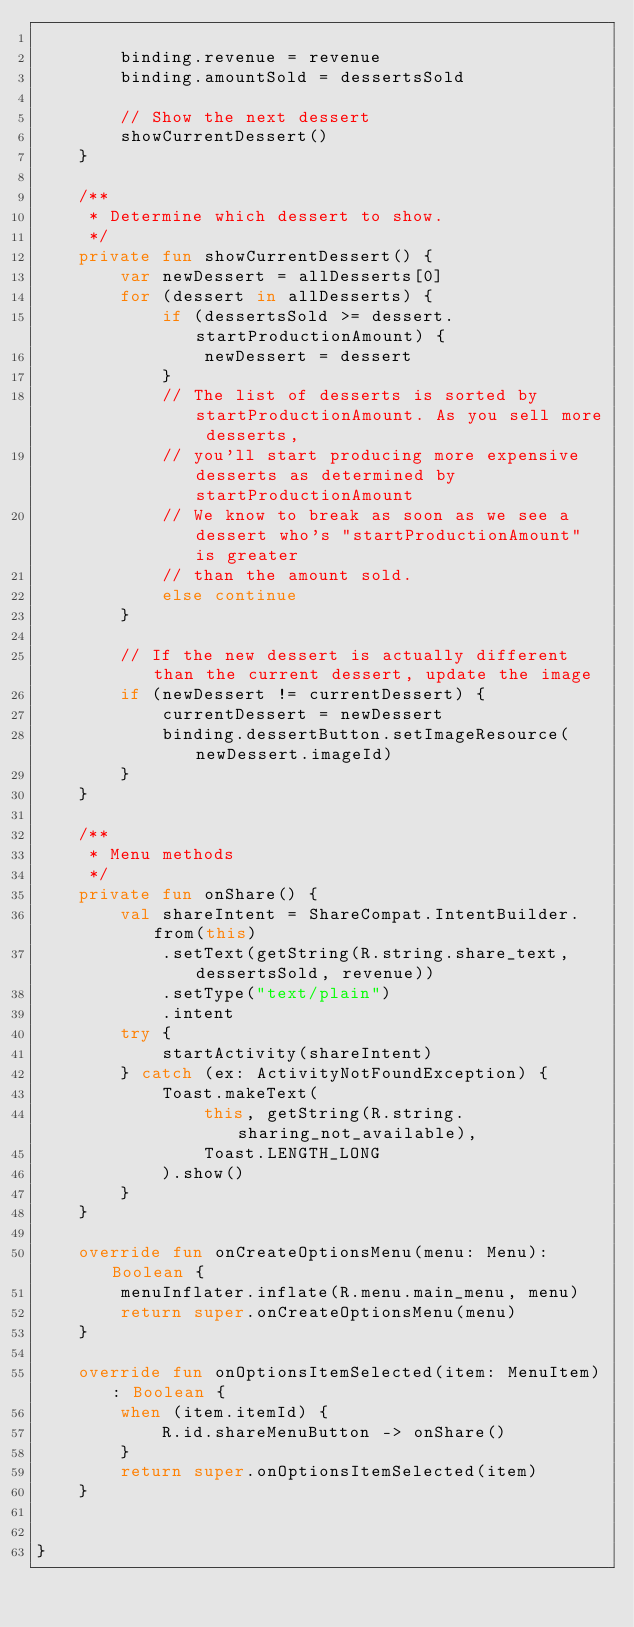Convert code to text. <code><loc_0><loc_0><loc_500><loc_500><_Kotlin_>
        binding.revenue = revenue
        binding.amountSold = dessertsSold

        // Show the next dessert
        showCurrentDessert()
    }

    /**
     * Determine which dessert to show.
     */
    private fun showCurrentDessert() {
        var newDessert = allDesserts[0]
        for (dessert in allDesserts) {
            if (dessertsSold >= dessert.startProductionAmount) {
                newDessert = dessert
            }
            // The list of desserts is sorted by startProductionAmount. As you sell more desserts,
            // you'll start producing more expensive desserts as determined by startProductionAmount
            // We know to break as soon as we see a dessert who's "startProductionAmount" is greater
            // than the amount sold.
            else continue
        }

        // If the new dessert is actually different than the current dessert, update the image
        if (newDessert != currentDessert) {
            currentDessert = newDessert
            binding.dessertButton.setImageResource(newDessert.imageId)
        }
    }

    /**
     * Menu methods
     */
    private fun onShare() {
        val shareIntent = ShareCompat.IntentBuilder.from(this)
            .setText(getString(R.string.share_text, dessertsSold, revenue))
            .setType("text/plain")
            .intent
        try {
            startActivity(shareIntent)
        } catch (ex: ActivityNotFoundException) {
            Toast.makeText(
                this, getString(R.string.sharing_not_available),
                Toast.LENGTH_LONG
            ).show()
        }
    }

    override fun onCreateOptionsMenu(menu: Menu): Boolean {
        menuInflater.inflate(R.menu.main_menu, menu)
        return super.onCreateOptionsMenu(menu)
    }

    override fun onOptionsItemSelected(item: MenuItem): Boolean {
        when (item.itemId) {
            R.id.shareMenuButton -> onShare()
        }
        return super.onOptionsItemSelected(item)
    }


}
</code> 